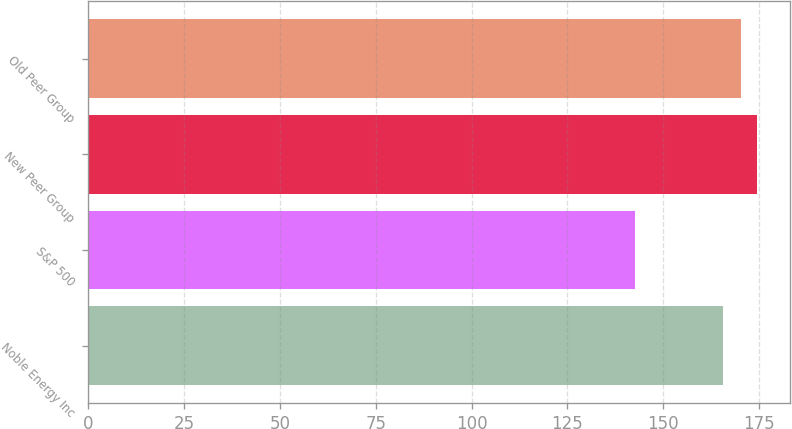Convert chart. <chart><loc_0><loc_0><loc_500><loc_500><bar_chart><fcel>Noble Energy Inc<fcel>S&P 500<fcel>New Peer Group<fcel>Old Peer Group<nl><fcel>165.66<fcel>142.69<fcel>174.5<fcel>170.44<nl></chart> 